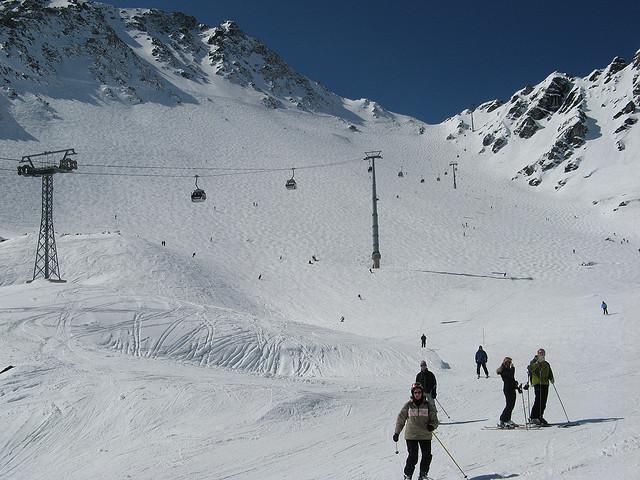How many people are in this photo?
Give a very brief answer. 7. 